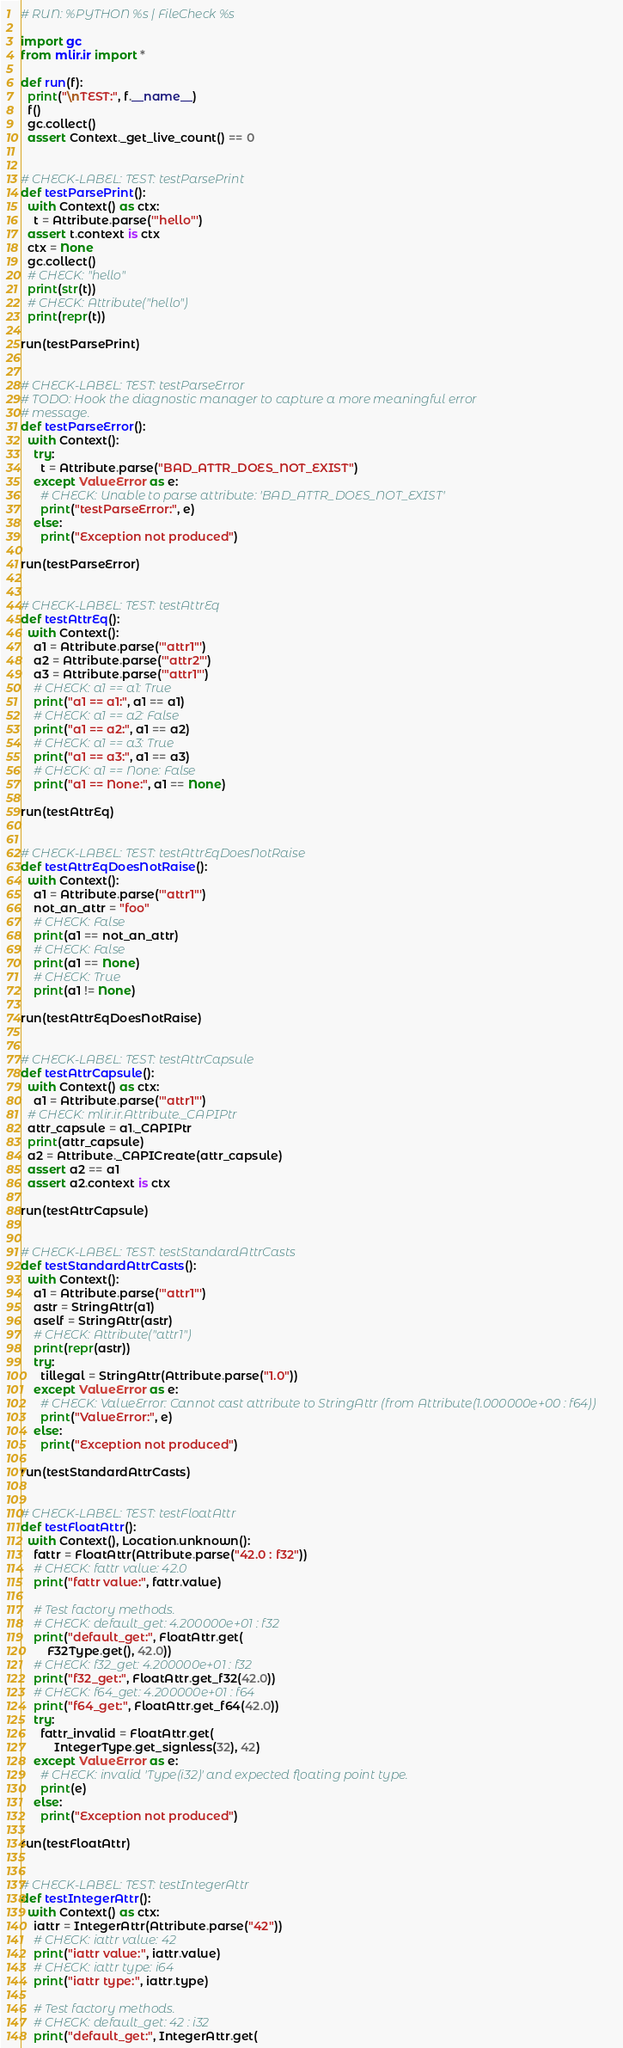Convert code to text. <code><loc_0><loc_0><loc_500><loc_500><_Python_># RUN: %PYTHON %s | FileCheck %s

import gc
from mlir.ir import *

def run(f):
  print("\nTEST:", f.__name__)
  f()
  gc.collect()
  assert Context._get_live_count() == 0


# CHECK-LABEL: TEST: testParsePrint
def testParsePrint():
  with Context() as ctx:
    t = Attribute.parse('"hello"')
  assert t.context is ctx
  ctx = None
  gc.collect()
  # CHECK: "hello"
  print(str(t))
  # CHECK: Attribute("hello")
  print(repr(t))

run(testParsePrint)


# CHECK-LABEL: TEST: testParseError
# TODO: Hook the diagnostic manager to capture a more meaningful error
# message.
def testParseError():
  with Context():
    try:
      t = Attribute.parse("BAD_ATTR_DOES_NOT_EXIST")
    except ValueError as e:
      # CHECK: Unable to parse attribute: 'BAD_ATTR_DOES_NOT_EXIST'
      print("testParseError:", e)
    else:
      print("Exception not produced")

run(testParseError)


# CHECK-LABEL: TEST: testAttrEq
def testAttrEq():
  with Context():
    a1 = Attribute.parse('"attr1"')
    a2 = Attribute.parse('"attr2"')
    a3 = Attribute.parse('"attr1"')
    # CHECK: a1 == a1: True
    print("a1 == a1:", a1 == a1)
    # CHECK: a1 == a2: False
    print("a1 == a2:", a1 == a2)
    # CHECK: a1 == a3: True
    print("a1 == a3:", a1 == a3)
    # CHECK: a1 == None: False
    print("a1 == None:", a1 == None)

run(testAttrEq)


# CHECK-LABEL: TEST: testAttrEqDoesNotRaise
def testAttrEqDoesNotRaise():
  with Context():
    a1 = Attribute.parse('"attr1"')
    not_an_attr = "foo"
    # CHECK: False
    print(a1 == not_an_attr)
    # CHECK: False
    print(a1 == None)
    # CHECK: True
    print(a1 != None)

run(testAttrEqDoesNotRaise)


# CHECK-LABEL: TEST: testAttrCapsule
def testAttrCapsule():
  with Context() as ctx:
    a1 = Attribute.parse('"attr1"')
  # CHECK: mlir.ir.Attribute._CAPIPtr
  attr_capsule = a1._CAPIPtr
  print(attr_capsule)
  a2 = Attribute._CAPICreate(attr_capsule)
  assert a2 == a1
  assert a2.context is ctx

run(testAttrCapsule)


# CHECK-LABEL: TEST: testStandardAttrCasts
def testStandardAttrCasts():
  with Context():
    a1 = Attribute.parse('"attr1"')
    astr = StringAttr(a1)
    aself = StringAttr(astr)
    # CHECK: Attribute("attr1")
    print(repr(astr))
    try:
      tillegal = StringAttr(Attribute.parse("1.0"))
    except ValueError as e:
      # CHECK: ValueError: Cannot cast attribute to StringAttr (from Attribute(1.000000e+00 : f64))
      print("ValueError:", e)
    else:
      print("Exception not produced")

run(testStandardAttrCasts)


# CHECK-LABEL: TEST: testFloatAttr
def testFloatAttr():
  with Context(), Location.unknown():
    fattr = FloatAttr(Attribute.parse("42.0 : f32"))
    # CHECK: fattr value: 42.0
    print("fattr value:", fattr.value)

    # Test factory methods.
    # CHECK: default_get: 4.200000e+01 : f32
    print("default_get:", FloatAttr.get(
        F32Type.get(), 42.0))
    # CHECK: f32_get: 4.200000e+01 : f32
    print("f32_get:", FloatAttr.get_f32(42.0))
    # CHECK: f64_get: 4.200000e+01 : f64
    print("f64_get:", FloatAttr.get_f64(42.0))
    try:
      fattr_invalid = FloatAttr.get(
          IntegerType.get_signless(32), 42)
    except ValueError as e:
      # CHECK: invalid 'Type(i32)' and expected floating point type.
      print(e)
    else:
      print("Exception not produced")

run(testFloatAttr)


# CHECK-LABEL: TEST: testIntegerAttr
def testIntegerAttr():
  with Context() as ctx:
    iattr = IntegerAttr(Attribute.parse("42"))
    # CHECK: iattr value: 42
    print("iattr value:", iattr.value)
    # CHECK: iattr type: i64
    print("iattr type:", iattr.type)

    # Test factory methods.
    # CHECK: default_get: 42 : i32
    print("default_get:", IntegerAttr.get(</code> 